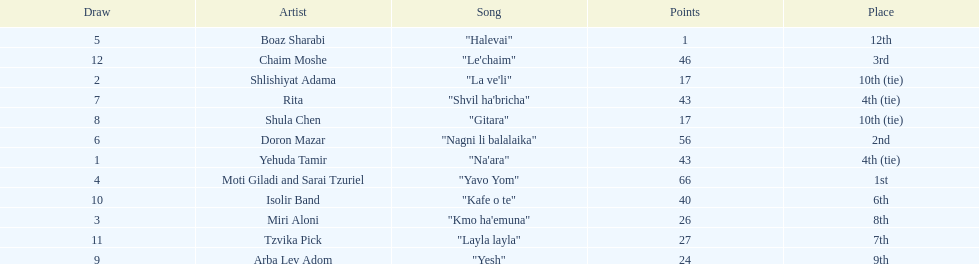What is the name of the song listed before the song "yesh"? "Gitara". 